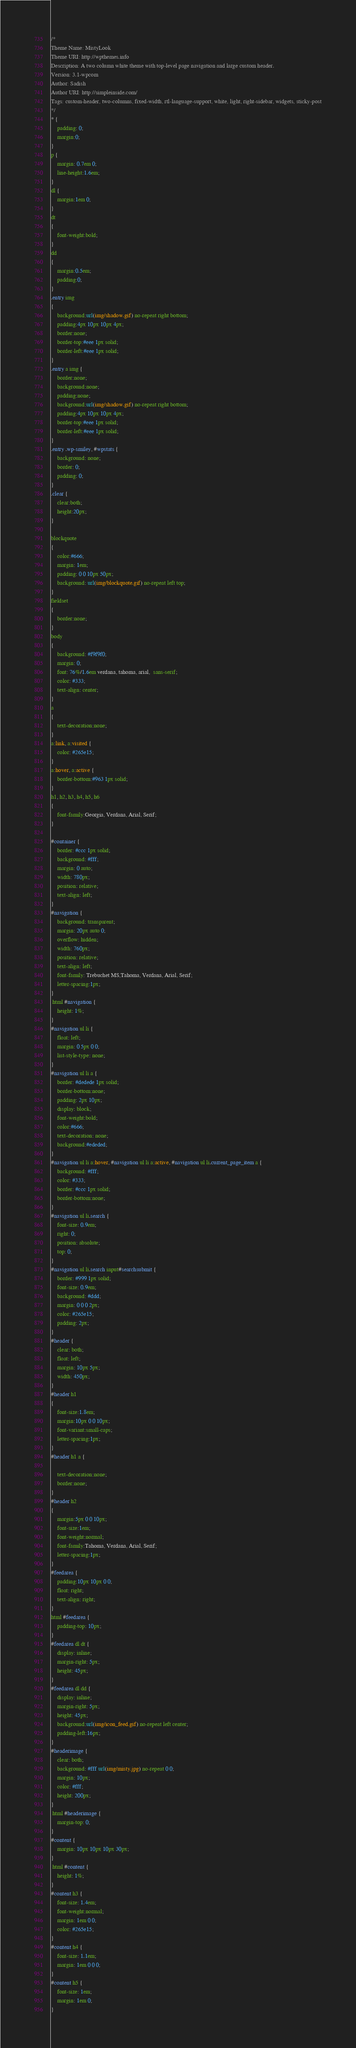Convert code to text. <code><loc_0><loc_0><loc_500><loc_500><_CSS_>/*  
Theme Name: MistyLook
Theme URI: http://wpthemes.info
Description: A two column white theme with top-level page navigation and large custom header.
Version: 3.1-wpcom
Author: Sadish
Author URI: http://simpleinside.com/
Tags: custom-header, two-columns, fixed-width, rtl-language-support, white, light, right-sidebar, widgets, sticky-post
*/
* {
	padding: 0; 
	margin:0;
}
p {
	margin: 0.7em 0;
	line-height:1.6em;
}
dl {
	margin:1em 0;
}
dt 
{
	font-weight:bold;
}
dd 
{
	margin:0.5em;
	padding:0;
}
.entry img 
{
	background:url(img/shadow.gif) no-repeat right bottom;
	padding:4px 10px 10px 4px;	
	border:none;
	border-top:#eee 1px solid;
	border-left:#eee 1px solid;	
}
.entry a img {
	border:none;
	background:none;
	padding:none;
	background:url(img/shadow.gif) no-repeat right bottom;
	padding:4px 10px 10px 4px;	
	border-top:#eee 1px solid;
	border-left:#eee 1px solid;	
}
.entry .wp-smiley, #wpstats {
	background: none;
	border: 0;
	padding: 0;
}
.clear {
	clear:both;
	height:20px;
}

blockquote
{
	color:#666;
	margin: 1em;
	padding: 0 0 10px 50px;
	background: url(img/blockquote.gif) no-repeat left top;	
}
fieldset 
{
	border:none;
}
body 
{
	background: #f9f9f0;
	margin: 0; 
	font: 76%/1.6em verdana, tahoma, arial,  sans-serif; 
	color: #333; 
	text-align: center;
}
a 
{
    text-decoration:none;
}
a:link, a:visited {
	color: #265e15;	
}
a:hover, a:active {
	border-bottom:#963 1px solid;
}
h1, h2, h3, h4, h5, h6 
{
	font-family:Georgia, Verdana, Arial, Serif;
}

#container {
	border: #ccc 1px solid; 
	background: #fff; 
	margin: 0 auto; 
	width: 780px; 	
	position: relative; 
	text-align: left;
}
#navigation {
	background: transparent; 
	margin: 20px auto 0; 
	overflow: hidden; 
	width: 760px; 
	position: relative; 
	text-align: left;
	font-family: Trebuchet MS,Tahoma, Verdana, Arial, Serif;
	letter-spacing:1px;
}
 html #navigation {
	height: 1%;
}
#navigation ul li {
	float: left; 
	margin: 0 5px 0 0; 
	list-style-type: none;
}
#navigation ul li a {
	border: #dedede 1px solid; 
	border-bottom:none;
	padding: 2px 10px; 
	display: block; 
	font-weight:bold;
	color:#666;		
	text-decoration: none;
	background:#ededed;
}
#navigation ul li a:hover, #navigation ul li a:active, #navigation ul li.current_page_item a {
	background: #fff;
	color: #333;	
	border: #ccc 1px solid; 
	border-bottom:none;		
}
#navigation ul li.search {
	font-size: 0.9em; 
	right: 0; 
	position: absolute; 
	top: 0;
}
#navigation ul li.search input#searchsubmit {
	border: #999 1px solid; 
	font-size: 0.9em; 
	background: #ddd; 
	margin: 0 0 0 2px; 
	color: #265e15; 
	padding: 2px; 		
}
#header {
	clear: both; 
	float: left; 
	margin: 10px 5px; 
	width: 450px;
}
#header h1 
{
	font-size:1.8em;
	margin:10px 0 0 10px;
	font-variant:small-caps;
	letter-spacing:1px;		
}
#header h1 a {
	
	text-decoration:none;	
	border:none;
}
#header h2 
{
	margin:5px 0 0 10px;
	font-size:1em;
	font-weight:normal;
	font-family:Tahoma, Verdana, Arial, Serif;
	letter-spacing:1px;		
}
#feedarea {
	padding:10px 10px 0 0; 
	float: right; 	
	text-align: right;
}
html #feedarea {
	padding-top: 10px;
}
#feedarea dl dt {
	display: inline; 
	margin-right: 5px; 
	height: 45px;
}
#feedarea dl dd {
	display: inline; 
	margin-right: 5px; 
	height: 45px;
	background:url(img/icon_feed.gif) no-repeat left center;
	padding-left:16px;
}
#headerimage {
	clear: both; 
	background: #fff url(img/misty.jpg) no-repeat 0 0;
	margin: 10px; 
	color: #fff; 
	height: 200px;
}
 html #headerimage {
	margin-top: 0;
}
#content {
	margin: 10px 10px 10px 30px; 	
}
 html #content {
	height: 1%;
}
#content h3 {
	font-size: 1.4em; 
	font-weight:normal;
	margin: 1em 0 0;
	color: #265e15;	
}
#content h4 {
	font-size: 1.1em; 
	margin: 1em 0 0 0;
}
#content h5 {
	font-size: 1em; 
	margin: 1em 0;
}</code> 